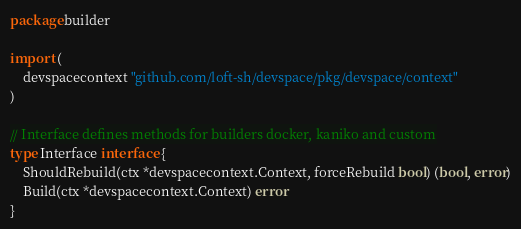Convert code to text. <code><loc_0><loc_0><loc_500><loc_500><_Go_>package builder

import (
	devspacecontext "github.com/loft-sh/devspace/pkg/devspace/context"
)

// Interface defines methods for builders docker, kaniko and custom
type Interface interface {
	ShouldRebuild(ctx *devspacecontext.Context, forceRebuild bool) (bool, error)
	Build(ctx *devspacecontext.Context) error
}
</code> 